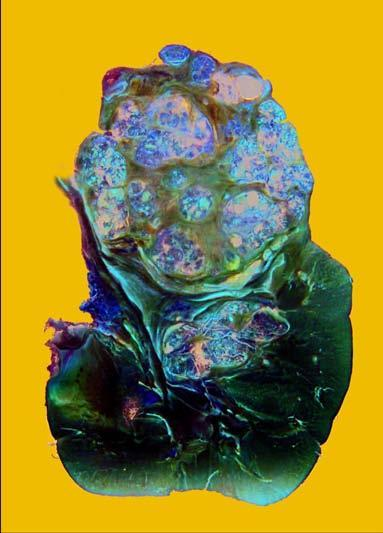does the upper pole of the kidney show a large and tan mass while rest of the kidney has reniform contour?
Answer the question using a single word or phrase. Yes 